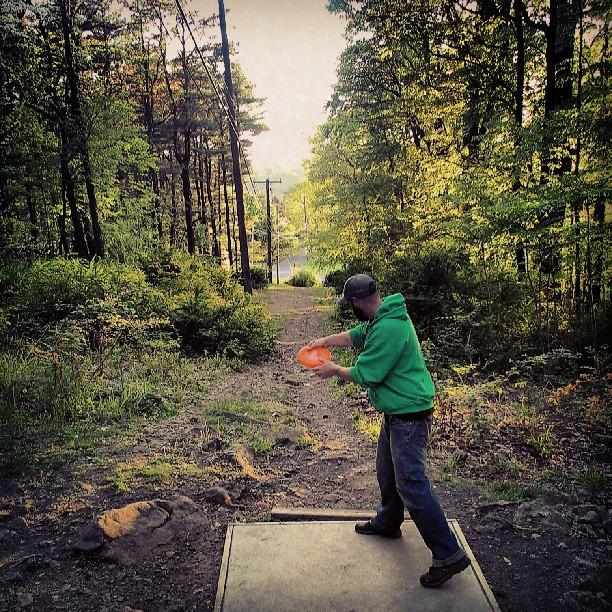The ground that the man is standing on is made of what material? wood 